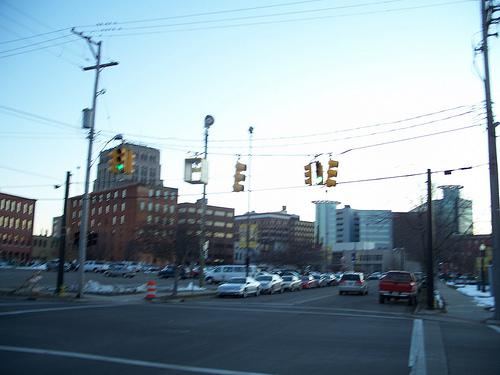Question: where was the picture taken?
Choices:
A. Downtown.
B. City street.
C. In Houston.
D. In Boston.
Answer with the letter. Answer: B Question: what is white?
Choices:
A. Snow.
B. The flowers.
C. The car.
D. Line on road.
Answer with the letter. Answer: D Question: what is brick?
Choices:
A. The school.
B. The walkway.
C. The church.
D. Building.
Answer with the letter. Answer: D Question: when will they move?
Choices:
A. Red light.
B. Yellow light.
C. When the cops say so.
D. Green light.
Answer with the letter. Answer: D 